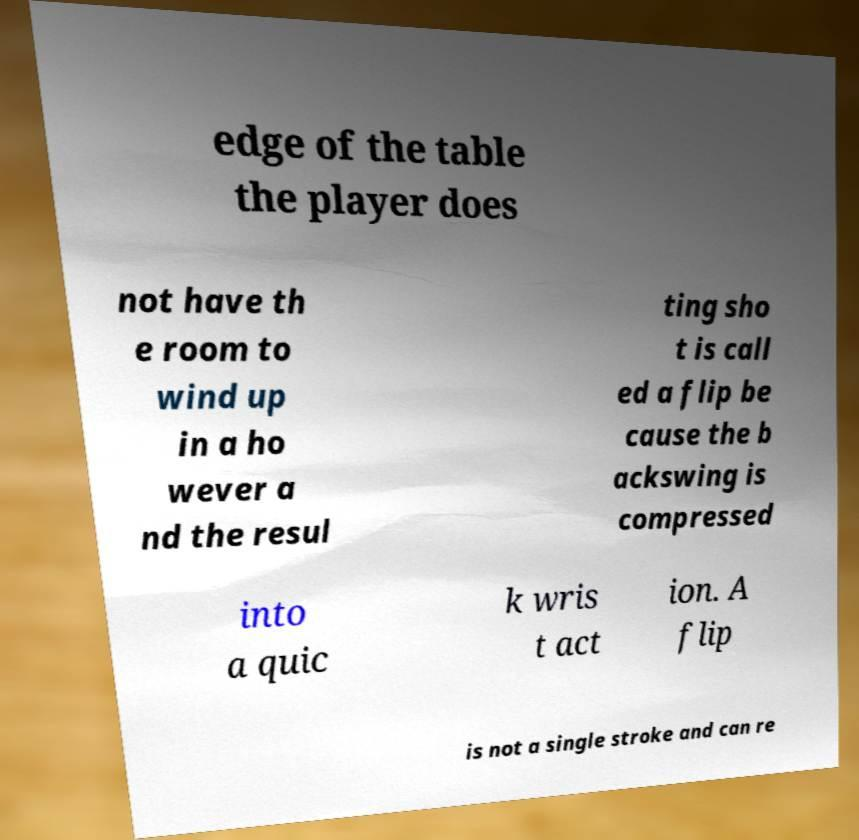For documentation purposes, I need the text within this image transcribed. Could you provide that? edge of the table the player does not have th e room to wind up in a ho wever a nd the resul ting sho t is call ed a flip be cause the b ackswing is compressed into a quic k wris t act ion. A flip is not a single stroke and can re 